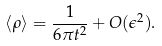<formula> <loc_0><loc_0><loc_500><loc_500>\langle \rho \rangle = \frac { 1 } { 6 \pi t ^ { 2 } } + O ( \epsilon ^ { 2 } ) .</formula> 